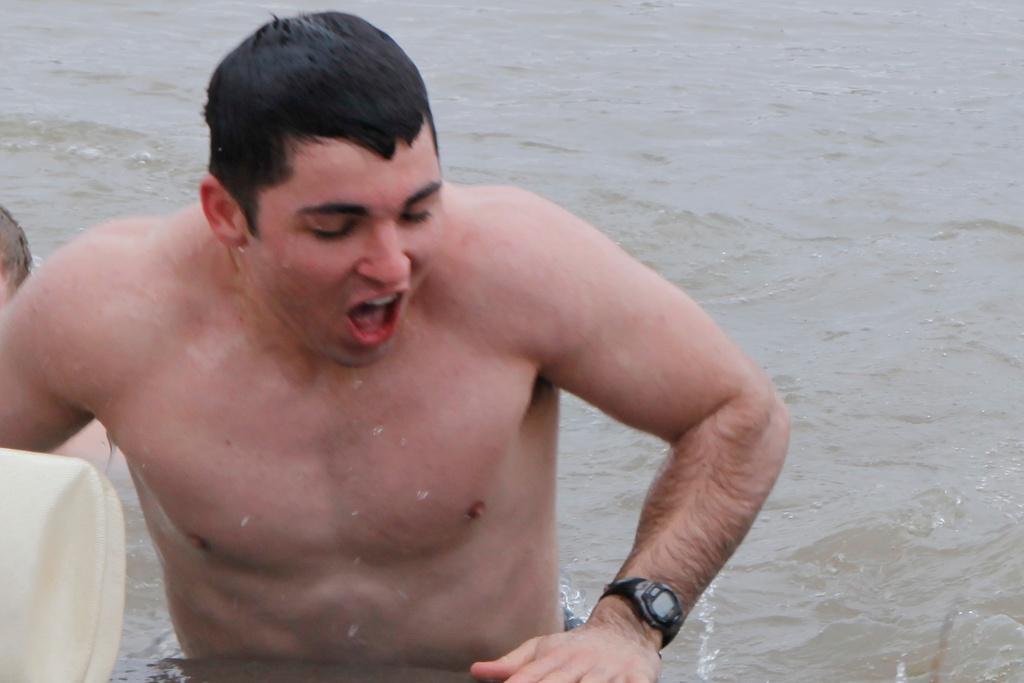Please provide a concise description of this image. In this image in the center there is one person who is in water beside him there is another person and some object, at the bottom there is a river. 